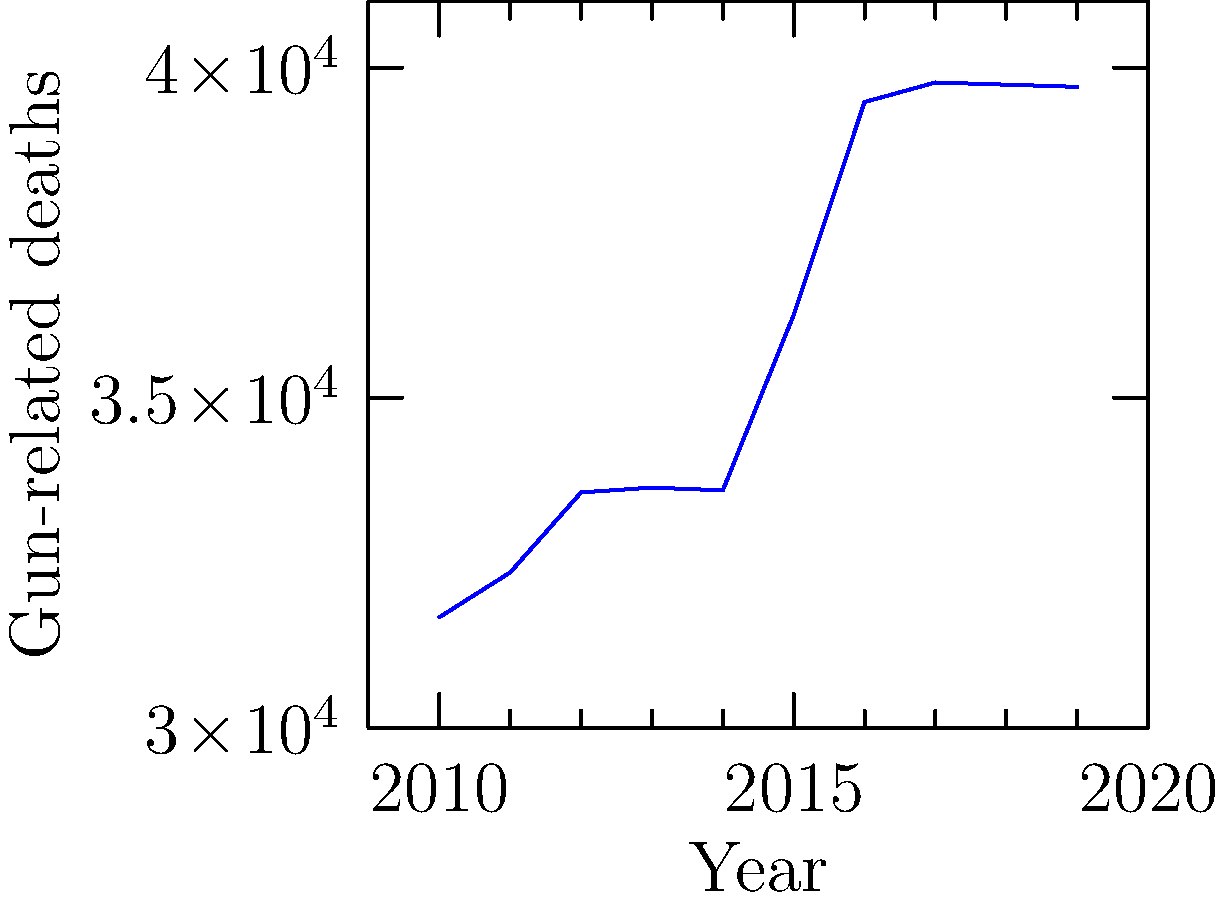Based on the line graph showing gun-related deaths in the United States from 2010 to 2019, what was the overall trend in gun-related fatalities during this period, and in which year did the sharpest increase occur? To answer this question, we need to analyze the trend and identify significant changes:

1. Overall trend:
   - In 2010, gun-related deaths were at their lowest point (31,672).
   - By 2019, the number had increased to 39,707.
   - The line shows a general upward trend throughout the decade.

2. Year-by-year analysis:
   2010 to 2011: Slight increase
   2011 to 2012: Moderate increase
   2012 to 2013: Slight increase
   2013 to 2014: Slight decrease
   2014 to 2015: Significant increase
   2015 to 2016: Sharp increase (largest jump)
   2016 to 2017: Slight increase
   2017 to 2018: Slight decrease
   2018 to 2019: Slight decrease

3. Sharpest increase:
   The most significant jump occurred between 2015 and 2016, with deaths increasing from 36,252 to 39,477 (a difference of 3,225).

Therefore, the overall trend was an increase in gun-related deaths, with the sharpest rise occurring in 2016.
Answer: Increasing trend; 2016 